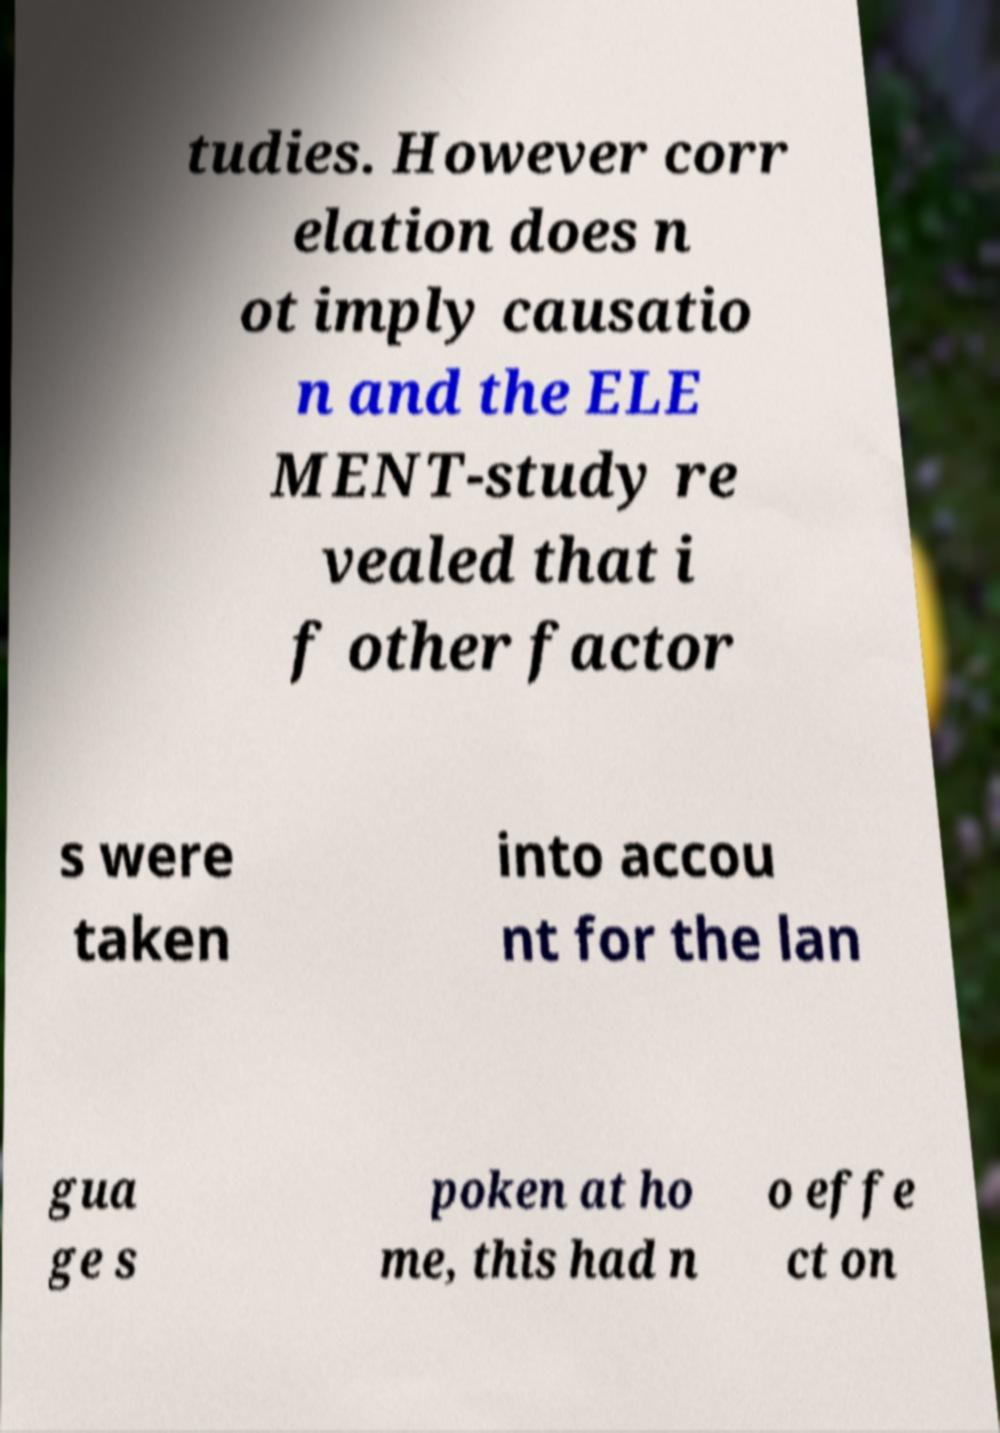There's text embedded in this image that I need extracted. Can you transcribe it verbatim? tudies. However corr elation does n ot imply causatio n and the ELE MENT-study re vealed that i f other factor s were taken into accou nt for the lan gua ge s poken at ho me, this had n o effe ct on 